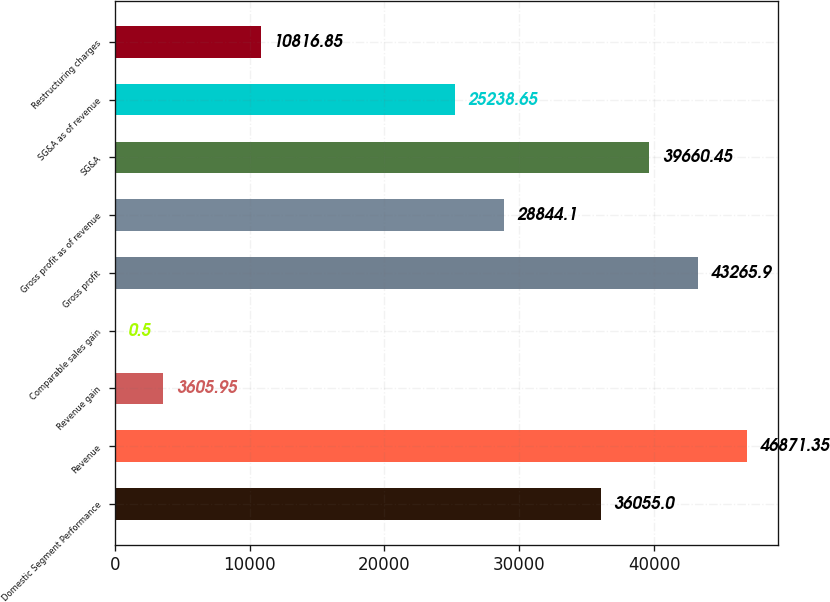<chart> <loc_0><loc_0><loc_500><loc_500><bar_chart><fcel>Domestic Segment Performance<fcel>Revenue<fcel>Revenue gain<fcel>Comparable sales gain<fcel>Gross profit<fcel>Gross profit as of revenue<fcel>SG&A<fcel>SG&A as of revenue<fcel>Restructuring charges<nl><fcel>36055<fcel>46871.3<fcel>3605.95<fcel>0.5<fcel>43265.9<fcel>28844.1<fcel>39660.4<fcel>25238.7<fcel>10816.9<nl></chart> 